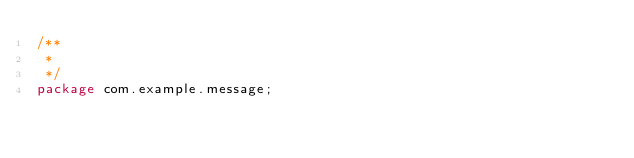Convert code to text. <code><loc_0><loc_0><loc_500><loc_500><_Java_>/**
 * 
 */
package com.example.message;</code> 